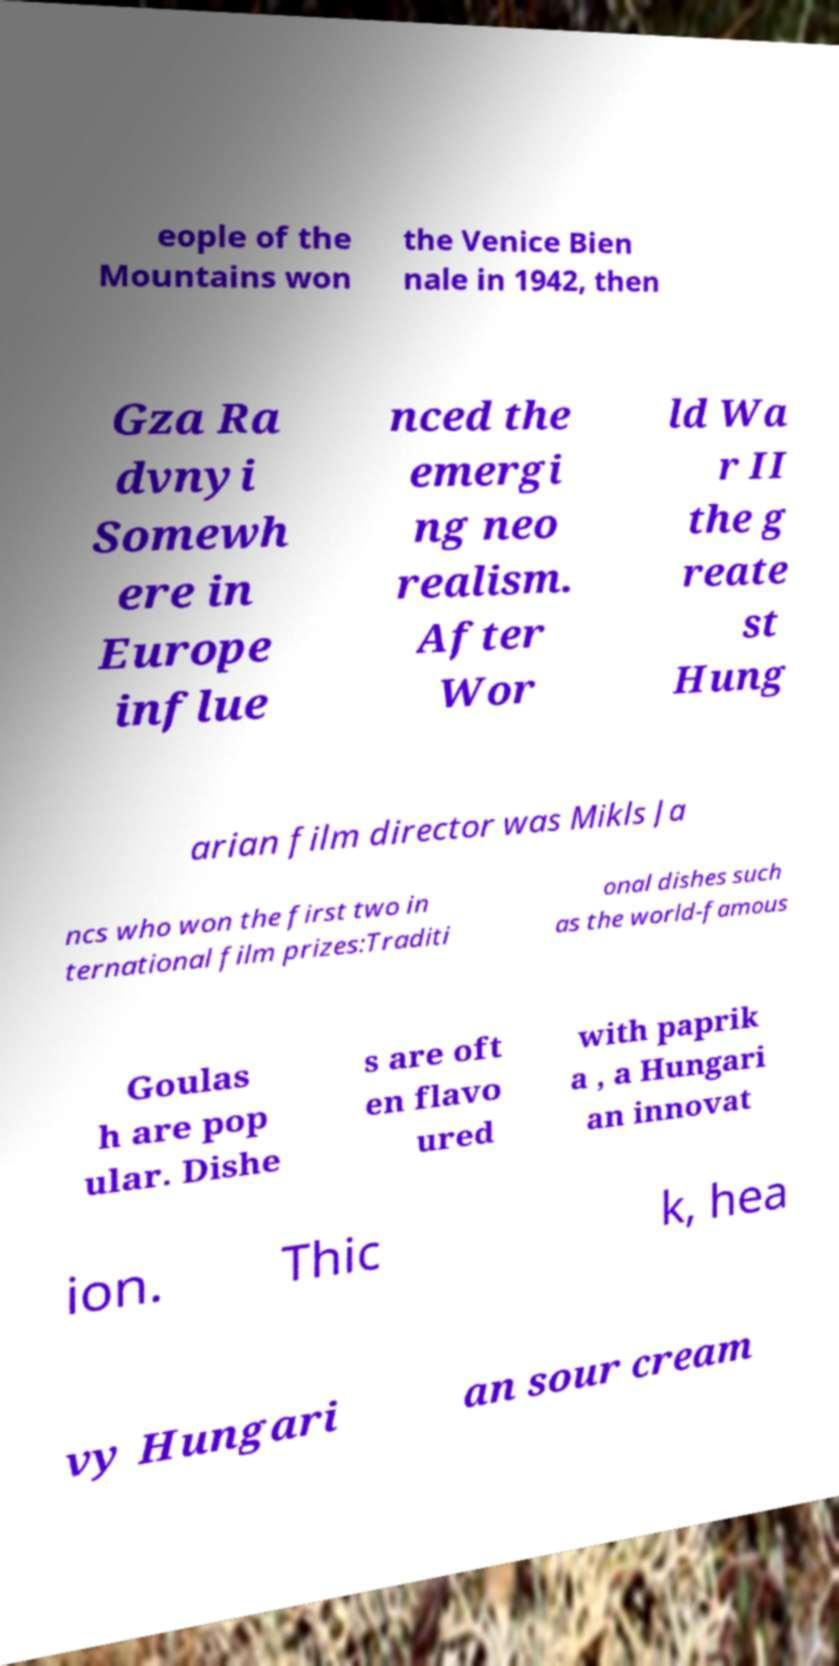What messages or text are displayed in this image? I need them in a readable, typed format. eople of the Mountains won the Venice Bien nale in 1942, then Gza Ra dvnyi Somewh ere in Europe influe nced the emergi ng neo realism. After Wor ld Wa r II the g reate st Hung arian film director was Mikls Ja ncs who won the first two in ternational film prizes:Traditi onal dishes such as the world-famous Goulas h are pop ular. Dishe s are oft en flavo ured with paprik a , a Hungari an innovat ion. Thic k, hea vy Hungari an sour cream 